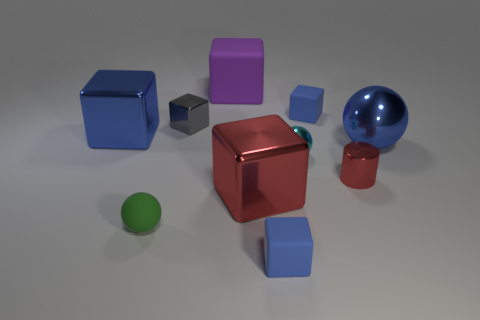Subtract all purple cylinders. How many blue blocks are left? 3 Subtract all purple blocks. How many blocks are left? 5 Subtract all blue matte blocks. How many blocks are left? 4 Subtract all yellow cubes. Subtract all blue cylinders. How many cubes are left? 6 Subtract all spheres. How many objects are left? 7 Add 4 big cyan cylinders. How many big cyan cylinders exist? 4 Subtract 0 blue cylinders. How many objects are left? 10 Subtract all large red objects. Subtract all blue things. How many objects are left? 5 Add 1 large cubes. How many large cubes are left? 4 